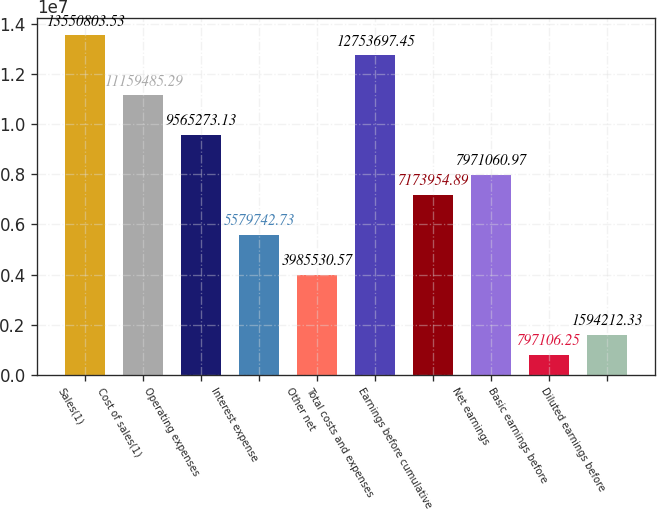Convert chart to OTSL. <chart><loc_0><loc_0><loc_500><loc_500><bar_chart><fcel>Sales(1)<fcel>Cost of sales(1)<fcel>Operating expenses<fcel>Interest expense<fcel>Other net<fcel>Total costs and expenses<fcel>Earnings before cumulative<fcel>Net earnings<fcel>Basic earnings before<fcel>Diluted earnings before<nl><fcel>1.35508e+07<fcel>1.11595e+07<fcel>9.56527e+06<fcel>5.57974e+06<fcel>3.98553e+06<fcel>1.27537e+07<fcel>7.17395e+06<fcel>7.97106e+06<fcel>797106<fcel>1.59421e+06<nl></chart> 